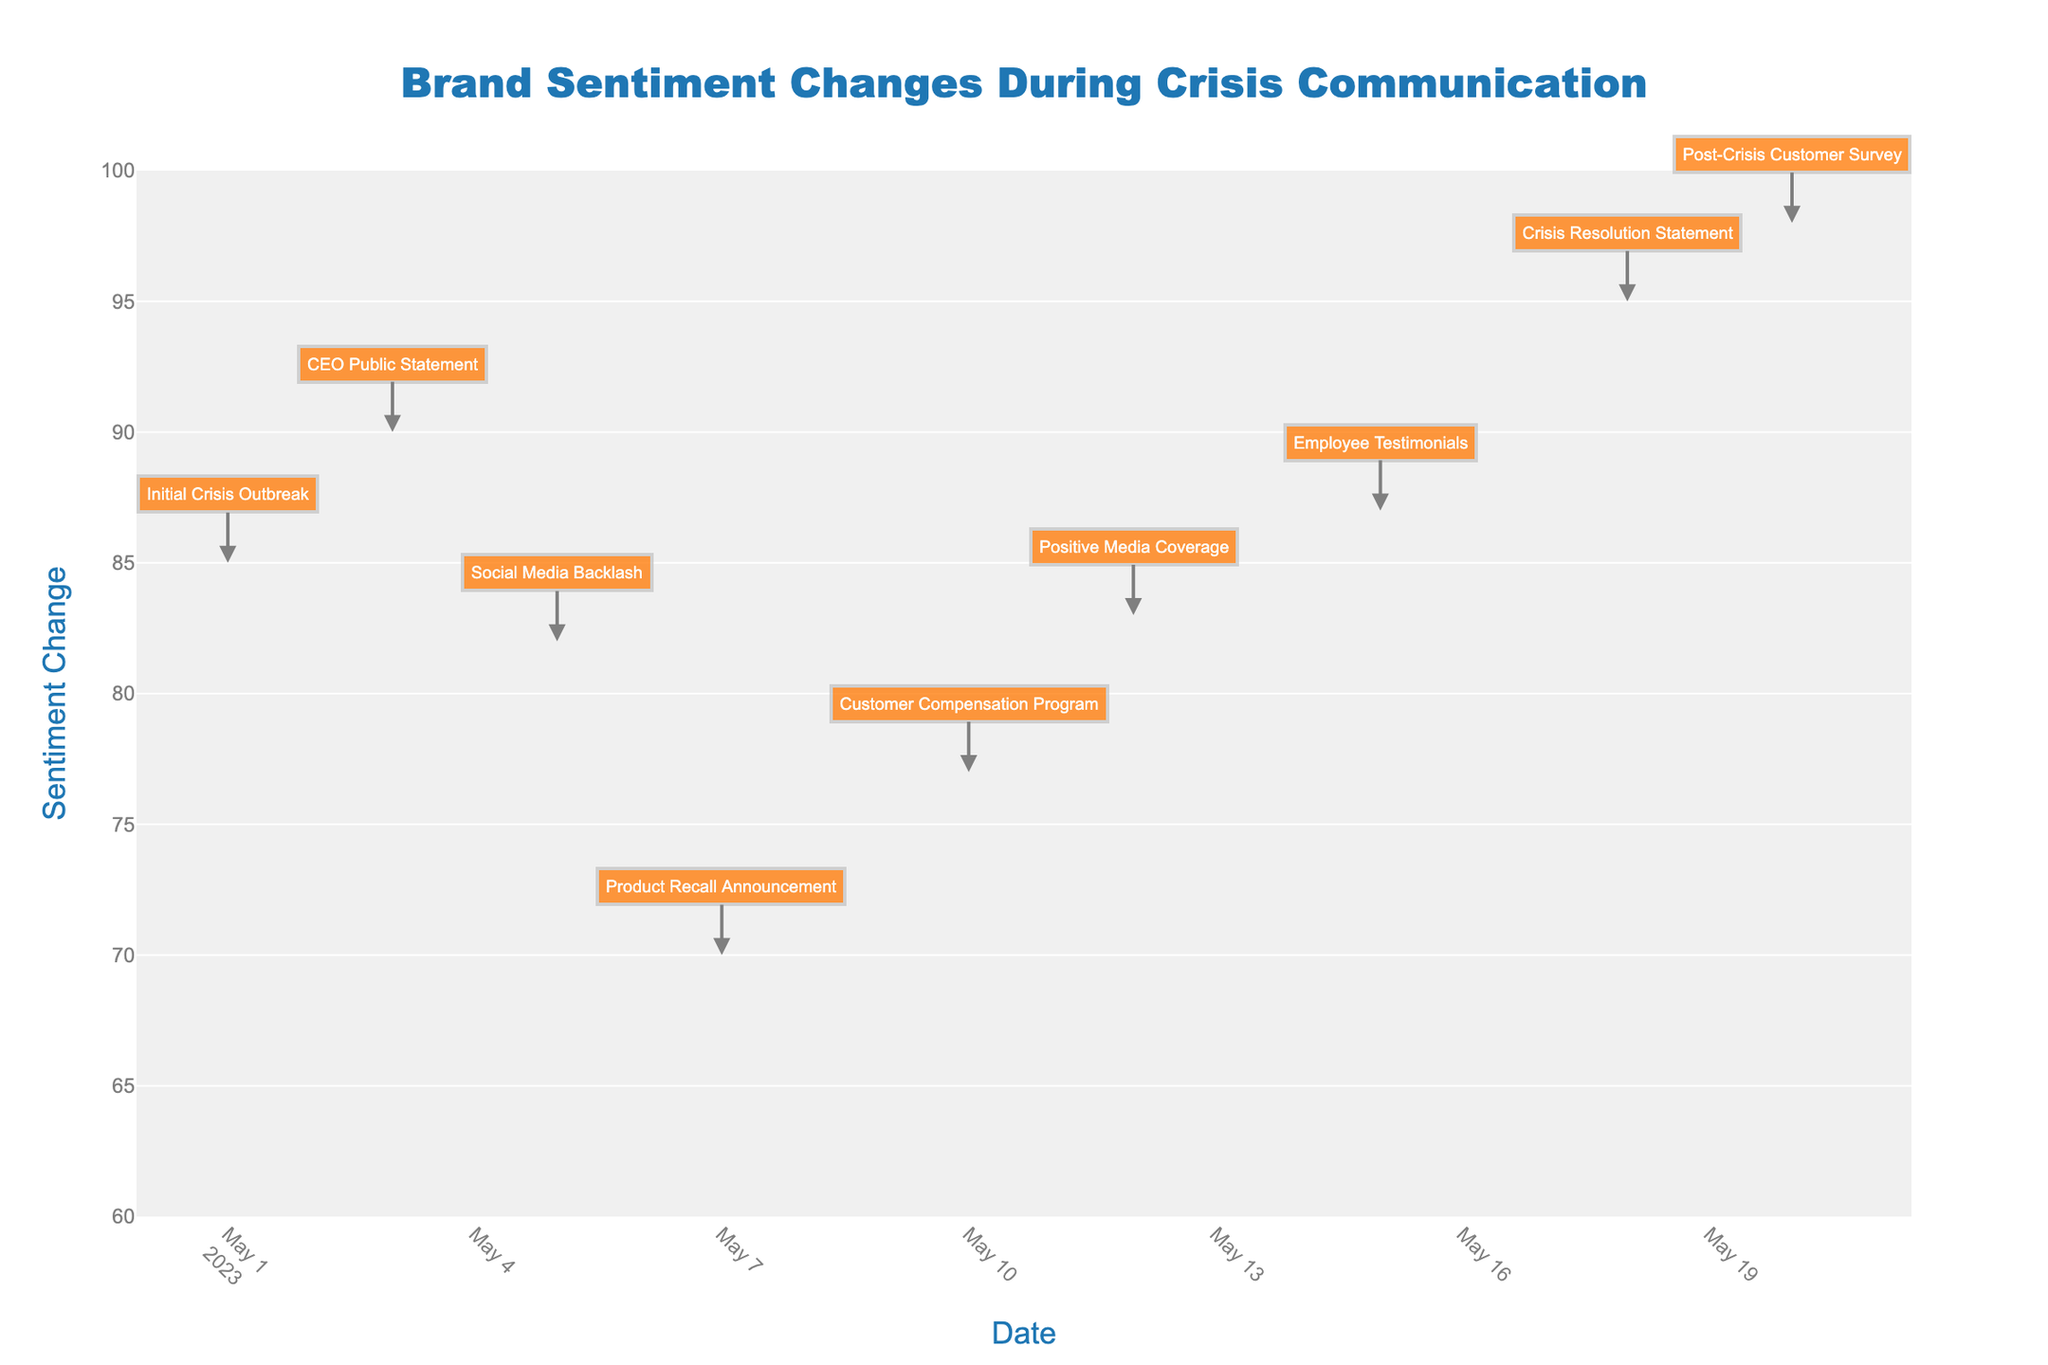What is the title of the chart? The title of the chart is displayed at the top and usually gives a summary of what the chart represents. In this case, it is "Brand Sentiment Changes During Crisis Communication".
Answer: "Brand Sentiment Changes During Crisis Communication" What was the sentiment change on May 10th? Sentiment change for each date can be identified by looking at the corresponding bar on the chart. On May 10th, the sentiment change shown in the diagram is 7.
Answer: 7 Which date had the largest negative sentiment change, and what was the value? We identify negative changes by looking at the red bars which indicate a decrease. The largest decrease will be the longest red bar. On May 7th, the product recall announcement caused the largest negative change of -12.
Answer: May 7th, -12 What is the final sentiment value shown on the chart? The final sentiment value is displayed as a sum of all changes and is often emphasized. In this chart, the final value is shown as the sum of the running total which is 98.
Answer: 98 How many events in total led to an increase in sentiment? Increasing events are shown as green bars. By counting these, we see that there are 5 events where the sentiment increased.
Answer: 5 What was the cumulative impact of the events on sentiment by May 20th? To find the cumulative impact, we look at the running total value on May 20th, which is 98. We start from an initial value, add up the changes (negative and positive), and arrive at the final value.
Answer: 98 How did the sentiment change between the CEO Public Statement on May 3rd and the Social Media Backlash on May 5th? To determine the change, we look at the sentiment values on both dates. On May 3rd, the CEO Public Statement increased sentiment by 5, and on May 5th, Social Media Backlash decreased sentiment by 8.
Answer: -3 Which event had the smallest positive impact on sentiment and what was its value? We look at the green bars to find the smallest one. The Employee Testimonials on May 15th had the smallest positive impact, increasing sentiment by 4.
Answer: Employee Testimonials, 4 What is the difference in sentiment change between the Customer Compensation Program on May 10th and the Employee Testimonials on May 15th? On May 10th, the sentiment increased by 7, and on May 15th, the sentiment increased by 4. The difference between these two values is 3.
Answer: 3 How much did the sentiment improve after the positive media coverage? The sentiment change due to Positive Media Coverage on May 12th was 6, which is the value by which the sentiment improved.
Answer: 6 